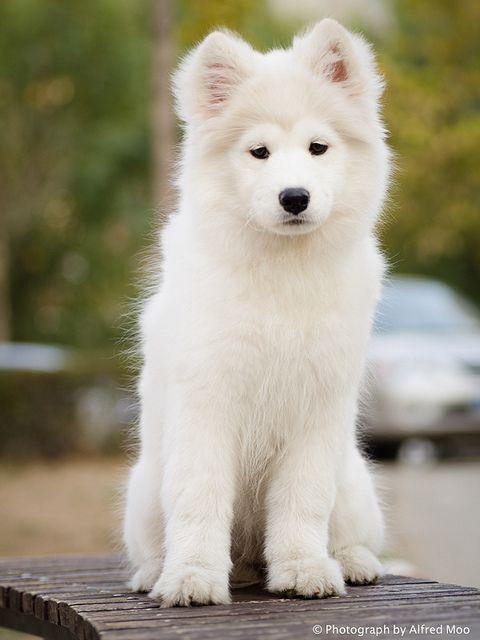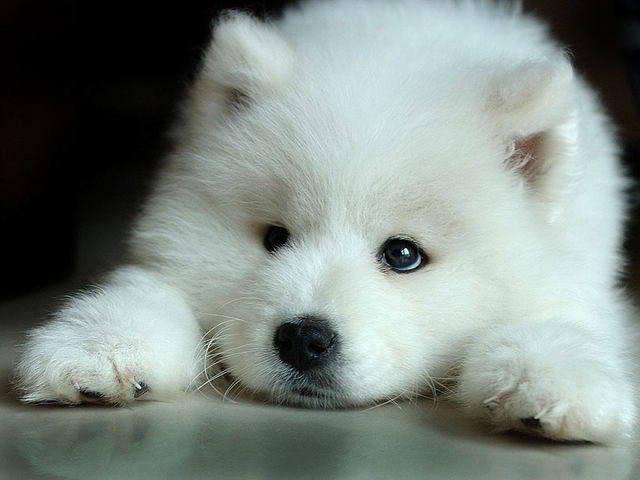The first image is the image on the left, the second image is the image on the right. Evaluate the accuracy of this statement regarding the images: "At least one dog's tongue is visible.". Is it true? Answer yes or no. No. 